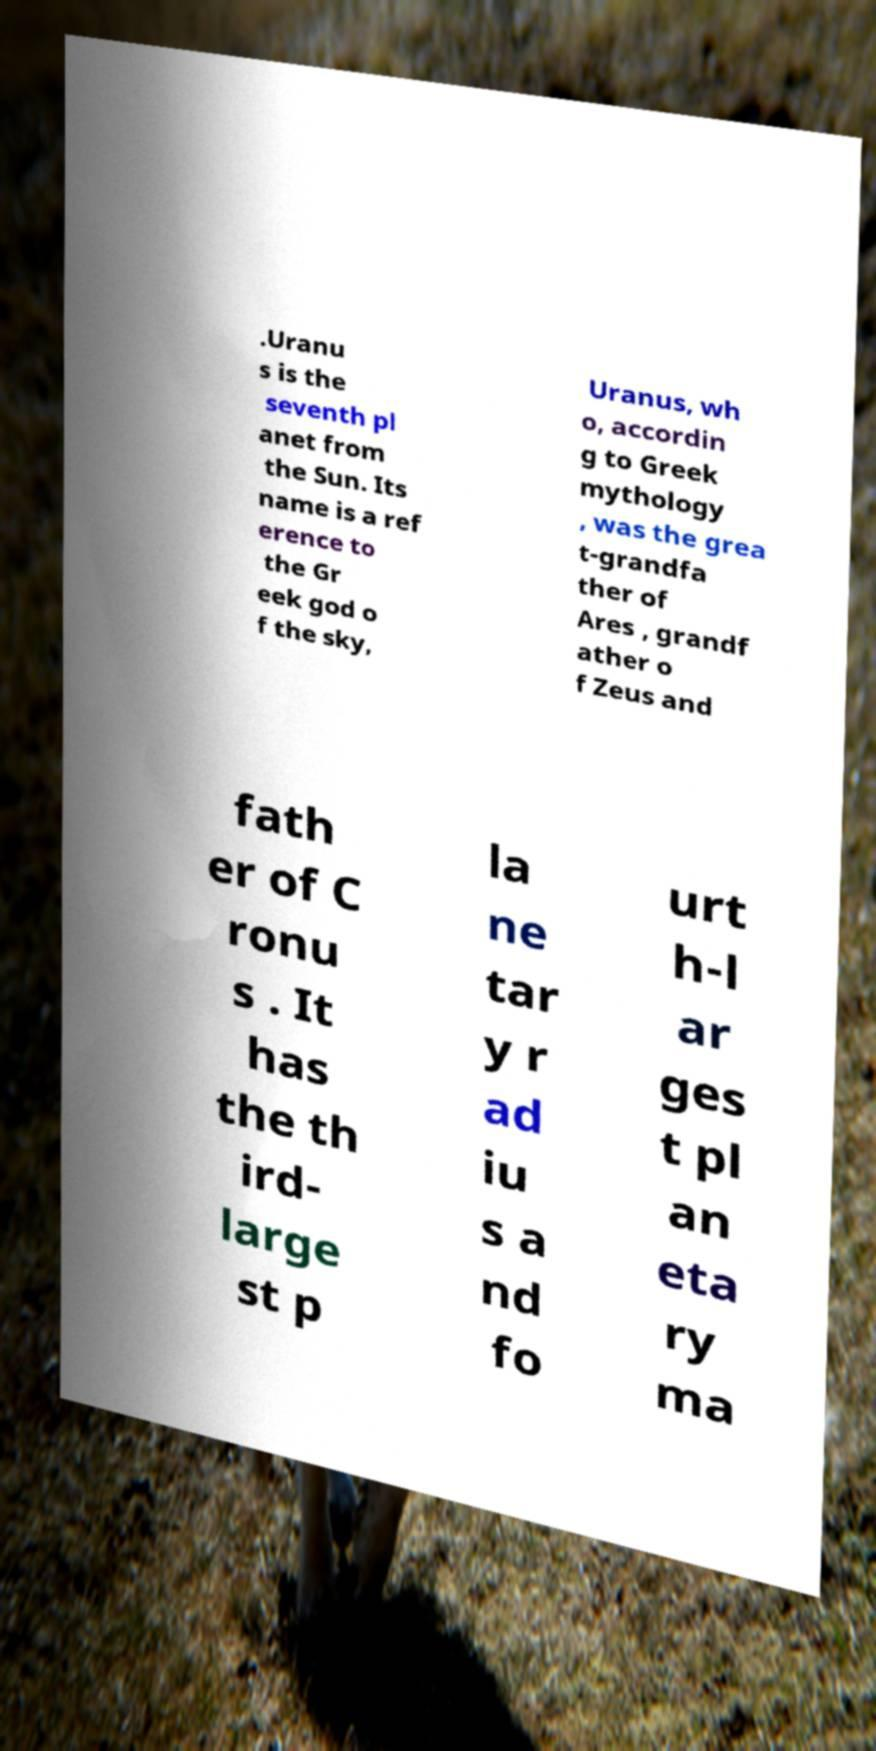Can you accurately transcribe the text from the provided image for me? .Uranu s is the seventh pl anet from the Sun. Its name is a ref erence to the Gr eek god o f the sky, Uranus, wh o, accordin g to Greek mythology , was the grea t-grandfa ther of Ares , grandf ather o f Zeus and fath er of C ronu s . It has the th ird- large st p la ne tar y r ad iu s a nd fo urt h-l ar ges t pl an eta ry ma 